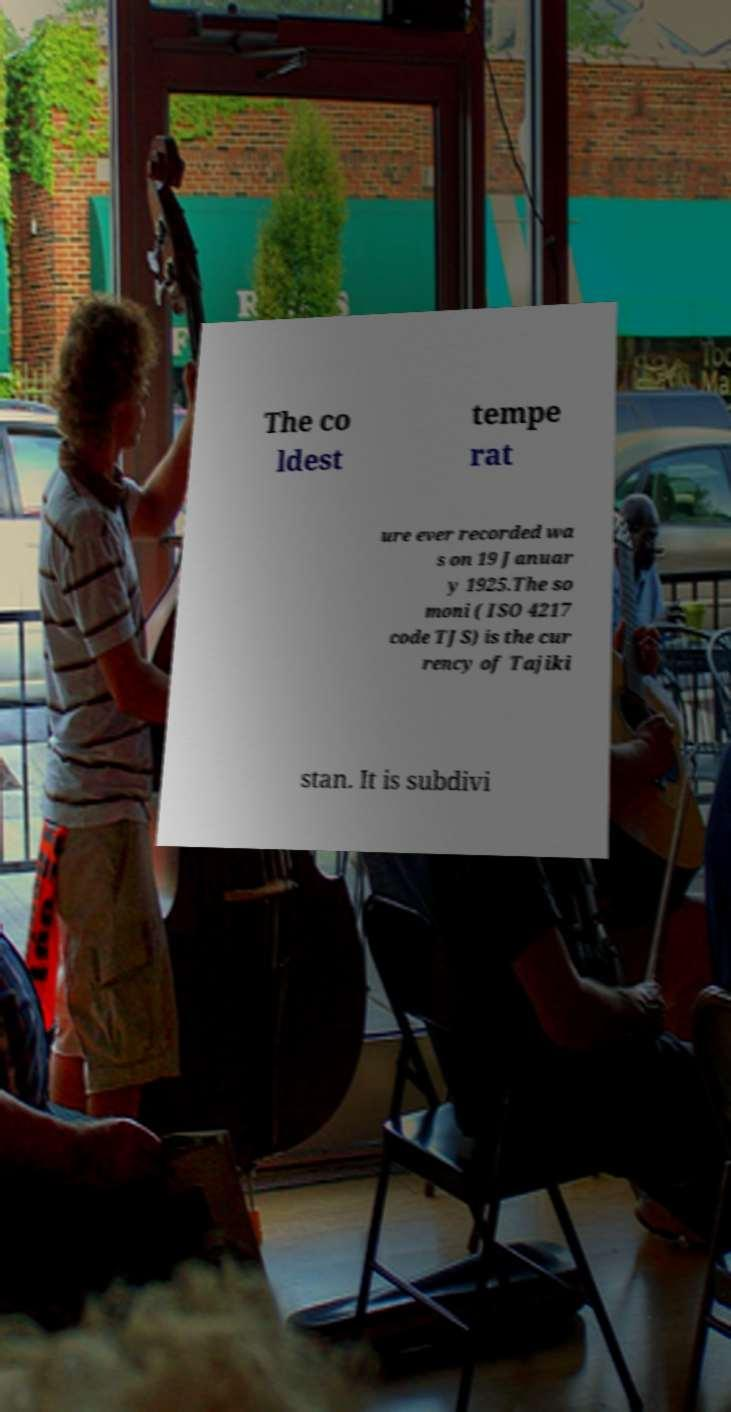Please read and relay the text visible in this image. What does it say? The co ldest tempe rat ure ever recorded wa s on 19 Januar y 1925.The so moni ( ISO 4217 code TJS) is the cur rency of Tajiki stan. It is subdivi 